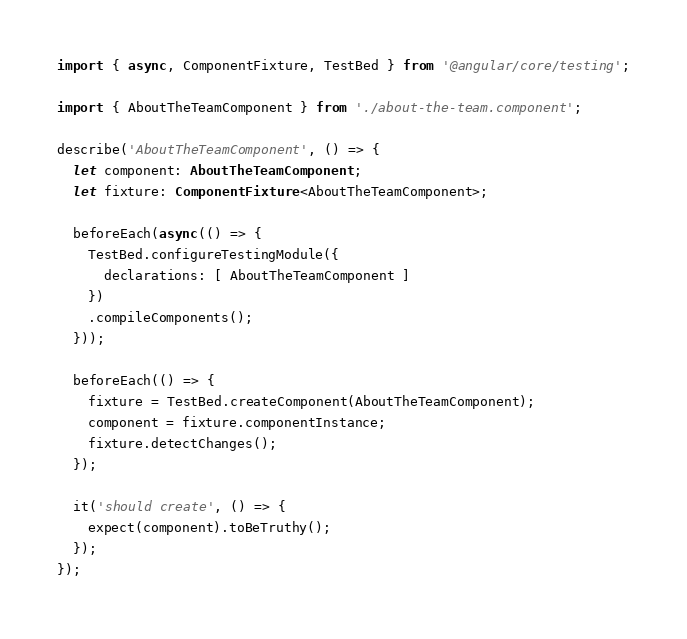<code> <loc_0><loc_0><loc_500><loc_500><_TypeScript_>import { async, ComponentFixture, TestBed } from '@angular/core/testing';

import { AboutTheTeamComponent } from './about-the-team.component';

describe('AboutTheTeamComponent', () => {
  let component: AboutTheTeamComponent;
  let fixture: ComponentFixture<AboutTheTeamComponent>;

  beforeEach(async(() => {
    TestBed.configureTestingModule({
      declarations: [ AboutTheTeamComponent ]
    })
    .compileComponents();
  }));

  beforeEach(() => {
    fixture = TestBed.createComponent(AboutTheTeamComponent);
    component = fixture.componentInstance;
    fixture.detectChanges();
  });

  it('should create', () => {
    expect(component).toBeTruthy();
  });
});
</code> 